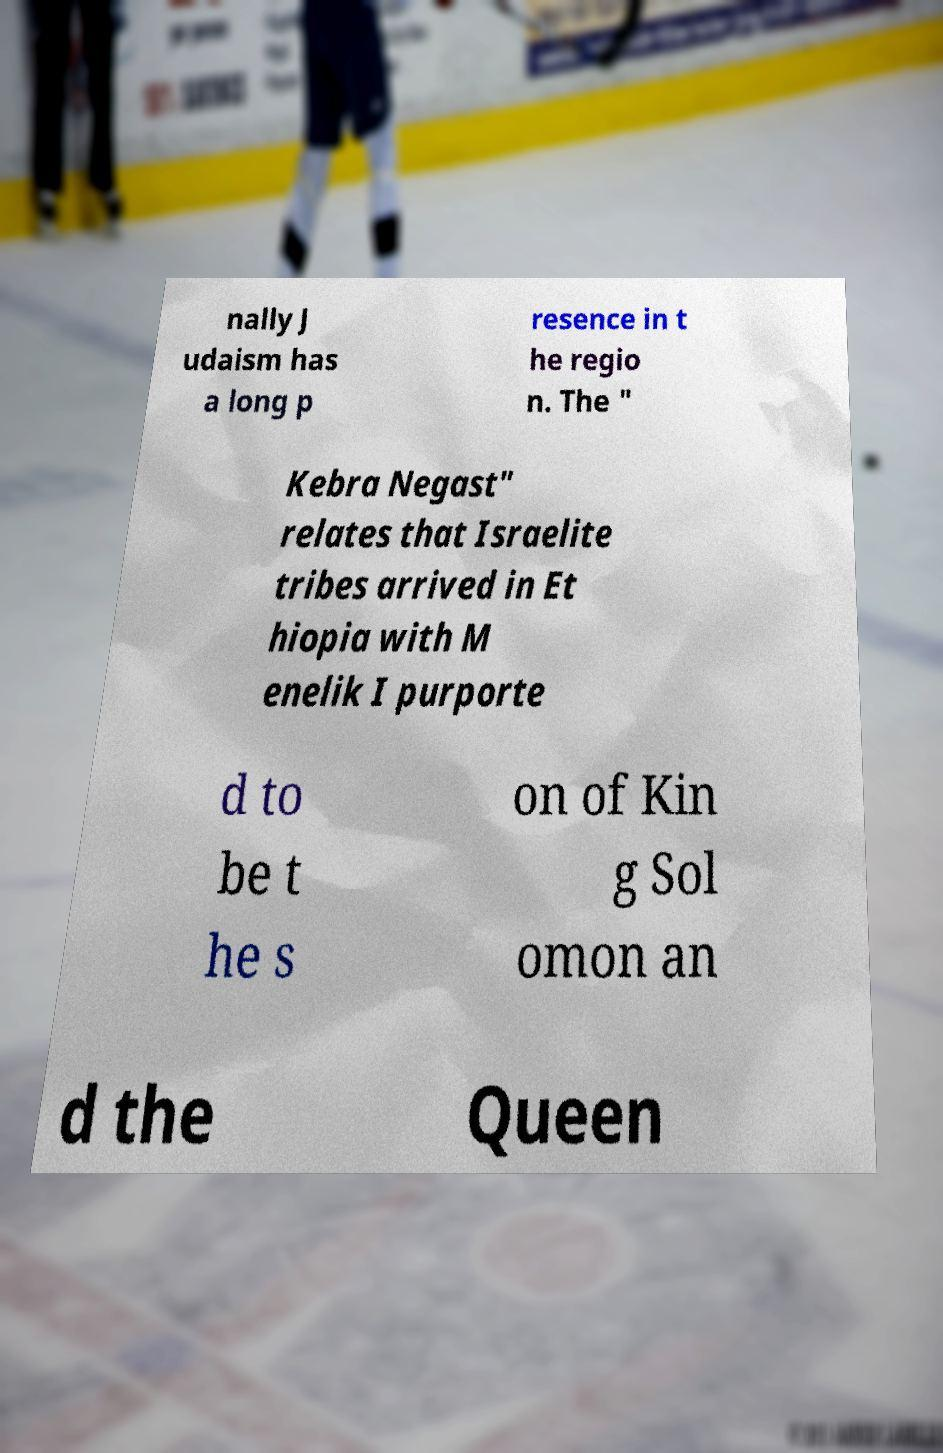For documentation purposes, I need the text within this image transcribed. Could you provide that? nally J udaism has a long p resence in t he regio n. The " Kebra Negast" relates that Israelite tribes arrived in Et hiopia with M enelik I purporte d to be t he s on of Kin g Sol omon an d the Queen 